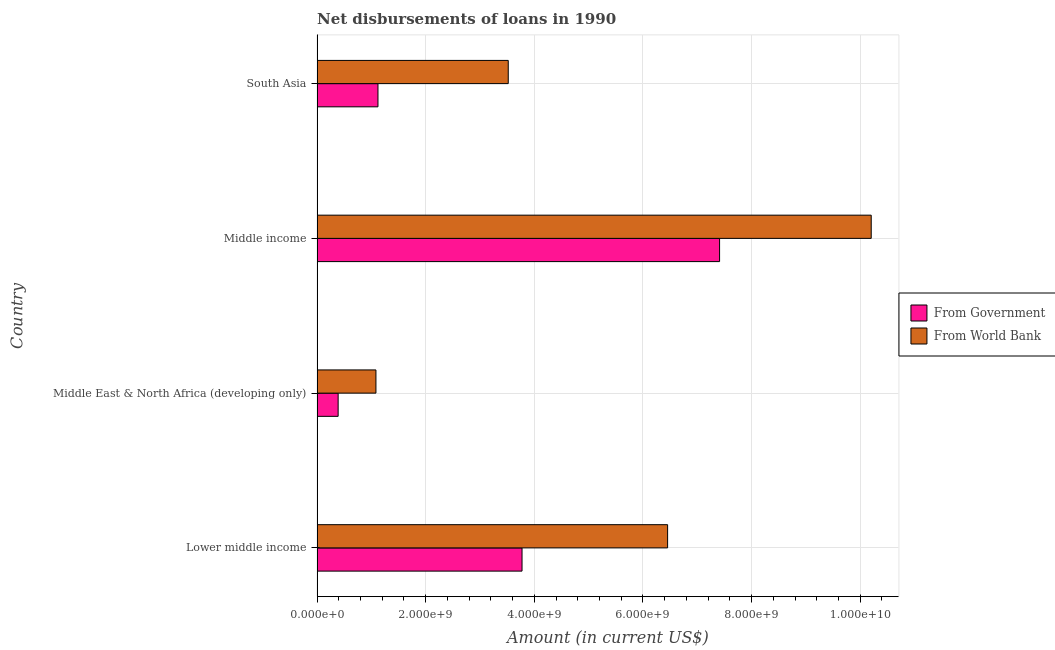Are the number of bars per tick equal to the number of legend labels?
Provide a succinct answer. Yes. Are the number of bars on each tick of the Y-axis equal?
Provide a short and direct response. Yes. How many bars are there on the 2nd tick from the top?
Provide a succinct answer. 2. How many bars are there on the 1st tick from the bottom?
Your answer should be compact. 2. What is the label of the 2nd group of bars from the top?
Keep it short and to the point. Middle income. In how many cases, is the number of bars for a given country not equal to the number of legend labels?
Your answer should be very brief. 0. What is the net disbursements of loan from world bank in Lower middle income?
Your response must be concise. 6.45e+09. Across all countries, what is the maximum net disbursements of loan from government?
Your response must be concise. 7.41e+09. Across all countries, what is the minimum net disbursements of loan from world bank?
Ensure brevity in your answer.  1.08e+09. In which country was the net disbursements of loan from government maximum?
Your response must be concise. Middle income. In which country was the net disbursements of loan from world bank minimum?
Give a very brief answer. Middle East & North Africa (developing only). What is the total net disbursements of loan from government in the graph?
Offer a very short reply. 1.27e+1. What is the difference between the net disbursements of loan from world bank in Lower middle income and that in Middle East & North Africa (developing only)?
Make the answer very short. 5.37e+09. What is the difference between the net disbursements of loan from government in Lower middle income and the net disbursements of loan from world bank in Middle East & North Africa (developing only)?
Give a very brief answer. 2.69e+09. What is the average net disbursements of loan from government per country?
Your answer should be compact. 3.17e+09. What is the difference between the net disbursements of loan from world bank and net disbursements of loan from government in Middle East & North Africa (developing only)?
Your answer should be very brief. 6.96e+08. What is the ratio of the net disbursements of loan from world bank in Lower middle income to that in Middle income?
Ensure brevity in your answer.  0.63. Is the difference between the net disbursements of loan from world bank in Lower middle income and Middle income greater than the difference between the net disbursements of loan from government in Lower middle income and Middle income?
Provide a short and direct response. No. What is the difference between the highest and the second highest net disbursements of loan from world bank?
Offer a very short reply. 3.75e+09. What is the difference between the highest and the lowest net disbursements of loan from world bank?
Your response must be concise. 9.12e+09. Is the sum of the net disbursements of loan from government in Lower middle income and South Asia greater than the maximum net disbursements of loan from world bank across all countries?
Your response must be concise. No. What does the 2nd bar from the top in South Asia represents?
Keep it short and to the point. From Government. What does the 2nd bar from the bottom in Middle income represents?
Make the answer very short. From World Bank. How many bars are there?
Your answer should be compact. 8. Are the values on the major ticks of X-axis written in scientific E-notation?
Give a very brief answer. Yes. Does the graph contain grids?
Make the answer very short. Yes. Where does the legend appear in the graph?
Keep it short and to the point. Center right. How are the legend labels stacked?
Your answer should be very brief. Vertical. What is the title of the graph?
Offer a very short reply. Net disbursements of loans in 1990. What is the label or title of the X-axis?
Offer a terse response. Amount (in current US$). What is the Amount (in current US$) in From Government in Lower middle income?
Offer a very short reply. 3.77e+09. What is the Amount (in current US$) of From World Bank in Lower middle income?
Your answer should be very brief. 6.45e+09. What is the Amount (in current US$) in From Government in Middle East & North Africa (developing only)?
Ensure brevity in your answer.  3.88e+08. What is the Amount (in current US$) of From World Bank in Middle East & North Africa (developing only)?
Give a very brief answer. 1.08e+09. What is the Amount (in current US$) of From Government in Middle income?
Ensure brevity in your answer.  7.41e+09. What is the Amount (in current US$) of From World Bank in Middle income?
Ensure brevity in your answer.  1.02e+1. What is the Amount (in current US$) of From Government in South Asia?
Your answer should be compact. 1.12e+09. What is the Amount (in current US$) in From World Bank in South Asia?
Offer a terse response. 3.52e+09. Across all countries, what is the maximum Amount (in current US$) of From Government?
Ensure brevity in your answer.  7.41e+09. Across all countries, what is the maximum Amount (in current US$) in From World Bank?
Ensure brevity in your answer.  1.02e+1. Across all countries, what is the minimum Amount (in current US$) in From Government?
Make the answer very short. 3.88e+08. Across all countries, what is the minimum Amount (in current US$) in From World Bank?
Ensure brevity in your answer.  1.08e+09. What is the total Amount (in current US$) in From Government in the graph?
Your answer should be compact. 1.27e+1. What is the total Amount (in current US$) in From World Bank in the graph?
Your answer should be compact. 2.13e+1. What is the difference between the Amount (in current US$) of From Government in Lower middle income and that in Middle East & North Africa (developing only)?
Your answer should be very brief. 3.39e+09. What is the difference between the Amount (in current US$) in From World Bank in Lower middle income and that in Middle East & North Africa (developing only)?
Your answer should be compact. 5.37e+09. What is the difference between the Amount (in current US$) in From Government in Lower middle income and that in Middle income?
Offer a terse response. -3.64e+09. What is the difference between the Amount (in current US$) of From World Bank in Lower middle income and that in Middle income?
Make the answer very short. -3.75e+09. What is the difference between the Amount (in current US$) of From Government in Lower middle income and that in South Asia?
Make the answer very short. 2.65e+09. What is the difference between the Amount (in current US$) of From World Bank in Lower middle income and that in South Asia?
Provide a short and direct response. 2.93e+09. What is the difference between the Amount (in current US$) of From Government in Middle East & North Africa (developing only) and that in Middle income?
Your answer should be very brief. -7.02e+09. What is the difference between the Amount (in current US$) of From World Bank in Middle East & North Africa (developing only) and that in Middle income?
Keep it short and to the point. -9.12e+09. What is the difference between the Amount (in current US$) in From Government in Middle East & North Africa (developing only) and that in South Asia?
Your answer should be compact. -7.33e+08. What is the difference between the Amount (in current US$) of From World Bank in Middle East & North Africa (developing only) and that in South Asia?
Provide a succinct answer. -2.44e+09. What is the difference between the Amount (in current US$) of From Government in Middle income and that in South Asia?
Offer a terse response. 6.29e+09. What is the difference between the Amount (in current US$) in From World Bank in Middle income and that in South Asia?
Provide a short and direct response. 6.68e+09. What is the difference between the Amount (in current US$) of From Government in Lower middle income and the Amount (in current US$) of From World Bank in Middle East & North Africa (developing only)?
Offer a very short reply. 2.69e+09. What is the difference between the Amount (in current US$) of From Government in Lower middle income and the Amount (in current US$) of From World Bank in Middle income?
Give a very brief answer. -6.43e+09. What is the difference between the Amount (in current US$) of From Government in Lower middle income and the Amount (in current US$) of From World Bank in South Asia?
Provide a succinct answer. 2.54e+08. What is the difference between the Amount (in current US$) of From Government in Middle East & North Africa (developing only) and the Amount (in current US$) of From World Bank in Middle income?
Make the answer very short. -9.81e+09. What is the difference between the Amount (in current US$) in From Government in Middle East & North Africa (developing only) and the Amount (in current US$) in From World Bank in South Asia?
Keep it short and to the point. -3.13e+09. What is the difference between the Amount (in current US$) in From Government in Middle income and the Amount (in current US$) in From World Bank in South Asia?
Keep it short and to the point. 3.89e+09. What is the average Amount (in current US$) in From Government per country?
Ensure brevity in your answer.  3.17e+09. What is the average Amount (in current US$) in From World Bank per country?
Provide a short and direct response. 5.32e+09. What is the difference between the Amount (in current US$) in From Government and Amount (in current US$) in From World Bank in Lower middle income?
Your answer should be very brief. -2.68e+09. What is the difference between the Amount (in current US$) in From Government and Amount (in current US$) in From World Bank in Middle East & North Africa (developing only)?
Offer a very short reply. -6.96e+08. What is the difference between the Amount (in current US$) of From Government and Amount (in current US$) of From World Bank in Middle income?
Your response must be concise. -2.79e+09. What is the difference between the Amount (in current US$) in From Government and Amount (in current US$) in From World Bank in South Asia?
Make the answer very short. -2.40e+09. What is the ratio of the Amount (in current US$) of From Government in Lower middle income to that in Middle East & North Africa (developing only)?
Provide a succinct answer. 9.72. What is the ratio of the Amount (in current US$) in From World Bank in Lower middle income to that in Middle East & North Africa (developing only)?
Your response must be concise. 5.95. What is the ratio of the Amount (in current US$) of From Government in Lower middle income to that in Middle income?
Provide a short and direct response. 0.51. What is the ratio of the Amount (in current US$) of From World Bank in Lower middle income to that in Middle income?
Give a very brief answer. 0.63. What is the ratio of the Amount (in current US$) in From Government in Lower middle income to that in South Asia?
Offer a terse response. 3.37. What is the ratio of the Amount (in current US$) of From World Bank in Lower middle income to that in South Asia?
Ensure brevity in your answer.  1.83. What is the ratio of the Amount (in current US$) of From Government in Middle East & North Africa (developing only) to that in Middle income?
Make the answer very short. 0.05. What is the ratio of the Amount (in current US$) of From World Bank in Middle East & North Africa (developing only) to that in Middle income?
Your response must be concise. 0.11. What is the ratio of the Amount (in current US$) of From Government in Middle East & North Africa (developing only) to that in South Asia?
Ensure brevity in your answer.  0.35. What is the ratio of the Amount (in current US$) of From World Bank in Middle East & North Africa (developing only) to that in South Asia?
Offer a very short reply. 0.31. What is the ratio of the Amount (in current US$) of From Government in Middle income to that in South Asia?
Offer a terse response. 6.61. What is the ratio of the Amount (in current US$) of From World Bank in Middle income to that in South Asia?
Provide a short and direct response. 2.9. What is the difference between the highest and the second highest Amount (in current US$) of From Government?
Your response must be concise. 3.64e+09. What is the difference between the highest and the second highest Amount (in current US$) in From World Bank?
Provide a succinct answer. 3.75e+09. What is the difference between the highest and the lowest Amount (in current US$) of From Government?
Give a very brief answer. 7.02e+09. What is the difference between the highest and the lowest Amount (in current US$) in From World Bank?
Ensure brevity in your answer.  9.12e+09. 